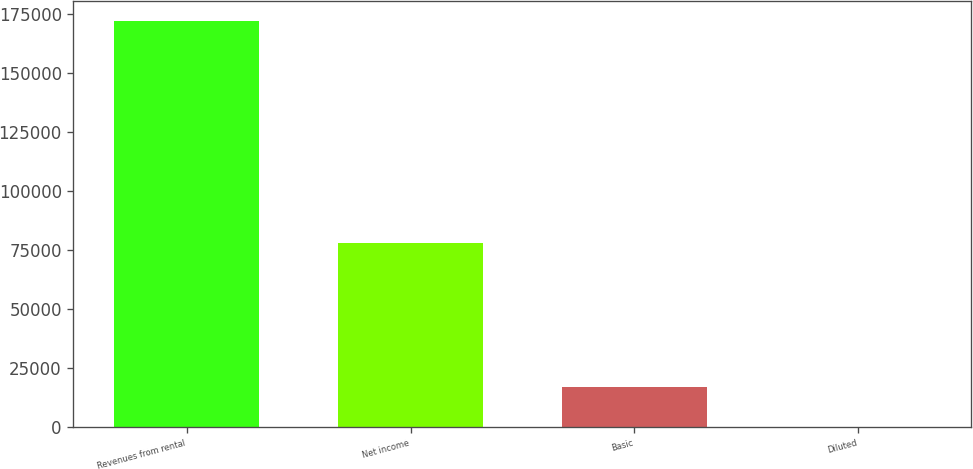Convert chart to OTSL. <chart><loc_0><loc_0><loc_500><loc_500><bar_chart><fcel>Revenues from rental<fcel>Net income<fcel>Basic<fcel>Diluted<nl><fcel>171906<fcel>78005<fcel>17190.9<fcel>0.29<nl></chart> 